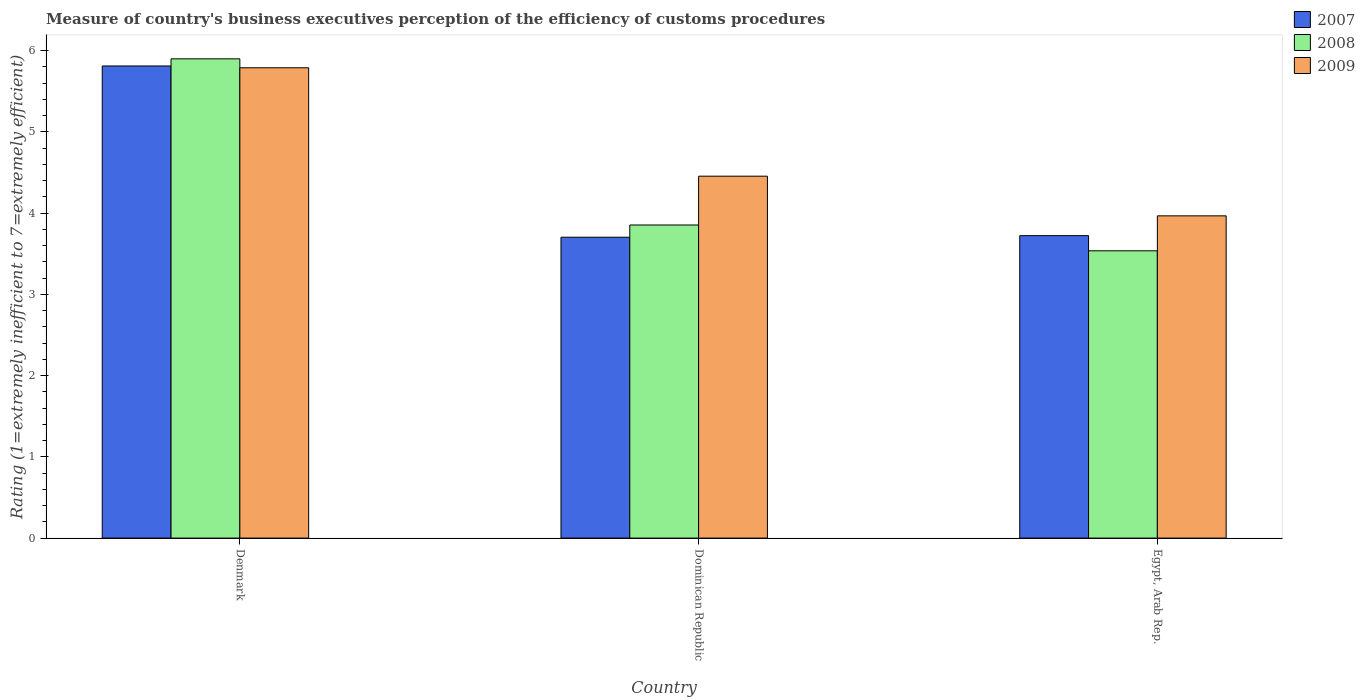How many groups of bars are there?
Give a very brief answer. 3. Are the number of bars per tick equal to the number of legend labels?
Ensure brevity in your answer.  Yes. What is the label of the 3rd group of bars from the left?
Your answer should be compact. Egypt, Arab Rep. What is the rating of the efficiency of customs procedure in 2009 in Denmark?
Offer a very short reply. 5.79. Across all countries, what is the maximum rating of the efficiency of customs procedure in 2009?
Give a very brief answer. 5.79. Across all countries, what is the minimum rating of the efficiency of customs procedure in 2008?
Provide a succinct answer. 3.54. In which country was the rating of the efficiency of customs procedure in 2008 minimum?
Make the answer very short. Egypt, Arab Rep. What is the total rating of the efficiency of customs procedure in 2008 in the graph?
Your answer should be compact. 13.29. What is the difference between the rating of the efficiency of customs procedure in 2007 in Dominican Republic and that in Egypt, Arab Rep.?
Keep it short and to the point. -0.02. What is the difference between the rating of the efficiency of customs procedure in 2008 in Denmark and the rating of the efficiency of customs procedure in 2009 in Egypt, Arab Rep.?
Make the answer very short. 1.93. What is the average rating of the efficiency of customs procedure in 2007 per country?
Your answer should be very brief. 4.41. What is the difference between the rating of the efficiency of customs procedure of/in 2009 and rating of the efficiency of customs procedure of/in 2007 in Dominican Republic?
Your answer should be very brief. 0.75. What is the ratio of the rating of the efficiency of customs procedure in 2009 in Denmark to that in Dominican Republic?
Keep it short and to the point. 1.3. What is the difference between the highest and the second highest rating of the efficiency of customs procedure in 2008?
Provide a succinct answer. -0.32. What is the difference between the highest and the lowest rating of the efficiency of customs procedure in 2007?
Ensure brevity in your answer.  2.11. In how many countries, is the rating of the efficiency of customs procedure in 2009 greater than the average rating of the efficiency of customs procedure in 2009 taken over all countries?
Your answer should be compact. 1. Is the sum of the rating of the efficiency of customs procedure in 2008 in Dominican Republic and Egypt, Arab Rep. greater than the maximum rating of the efficiency of customs procedure in 2007 across all countries?
Offer a very short reply. Yes. What does the 2nd bar from the left in Egypt, Arab Rep. represents?
Offer a terse response. 2008. Is it the case that in every country, the sum of the rating of the efficiency of customs procedure in 2008 and rating of the efficiency of customs procedure in 2009 is greater than the rating of the efficiency of customs procedure in 2007?
Offer a very short reply. Yes. How many bars are there?
Your answer should be very brief. 9. Are the values on the major ticks of Y-axis written in scientific E-notation?
Ensure brevity in your answer.  No. Does the graph contain any zero values?
Your answer should be compact. No. Where does the legend appear in the graph?
Your answer should be very brief. Top right. How many legend labels are there?
Make the answer very short. 3. What is the title of the graph?
Keep it short and to the point. Measure of country's business executives perception of the efficiency of customs procedures. What is the label or title of the Y-axis?
Give a very brief answer. Rating (1=extremely inefficient to 7=extremely efficient). What is the Rating (1=extremely inefficient to 7=extremely efficient) of 2007 in Denmark?
Keep it short and to the point. 5.81. What is the Rating (1=extremely inefficient to 7=extremely efficient) of 2008 in Denmark?
Provide a short and direct response. 5.9. What is the Rating (1=extremely inefficient to 7=extremely efficient) in 2009 in Denmark?
Your answer should be compact. 5.79. What is the Rating (1=extremely inefficient to 7=extremely efficient) of 2007 in Dominican Republic?
Keep it short and to the point. 3.7. What is the Rating (1=extremely inefficient to 7=extremely efficient) in 2008 in Dominican Republic?
Your answer should be very brief. 3.85. What is the Rating (1=extremely inefficient to 7=extremely efficient) of 2009 in Dominican Republic?
Your response must be concise. 4.46. What is the Rating (1=extremely inefficient to 7=extremely efficient) of 2007 in Egypt, Arab Rep.?
Provide a short and direct response. 3.72. What is the Rating (1=extremely inefficient to 7=extremely efficient) of 2008 in Egypt, Arab Rep.?
Offer a terse response. 3.54. What is the Rating (1=extremely inefficient to 7=extremely efficient) in 2009 in Egypt, Arab Rep.?
Offer a very short reply. 3.97. Across all countries, what is the maximum Rating (1=extremely inefficient to 7=extremely efficient) of 2007?
Keep it short and to the point. 5.81. Across all countries, what is the maximum Rating (1=extremely inefficient to 7=extremely efficient) of 2008?
Provide a short and direct response. 5.9. Across all countries, what is the maximum Rating (1=extremely inefficient to 7=extremely efficient) in 2009?
Offer a very short reply. 5.79. Across all countries, what is the minimum Rating (1=extremely inefficient to 7=extremely efficient) in 2007?
Offer a very short reply. 3.7. Across all countries, what is the minimum Rating (1=extremely inefficient to 7=extremely efficient) of 2008?
Offer a very short reply. 3.54. Across all countries, what is the minimum Rating (1=extremely inefficient to 7=extremely efficient) in 2009?
Make the answer very short. 3.97. What is the total Rating (1=extremely inefficient to 7=extremely efficient) in 2007 in the graph?
Your answer should be very brief. 13.24. What is the total Rating (1=extremely inefficient to 7=extremely efficient) in 2008 in the graph?
Provide a succinct answer. 13.29. What is the total Rating (1=extremely inefficient to 7=extremely efficient) in 2009 in the graph?
Make the answer very short. 14.21. What is the difference between the Rating (1=extremely inefficient to 7=extremely efficient) in 2007 in Denmark and that in Dominican Republic?
Make the answer very short. 2.11. What is the difference between the Rating (1=extremely inefficient to 7=extremely efficient) in 2008 in Denmark and that in Dominican Republic?
Give a very brief answer. 2.05. What is the difference between the Rating (1=extremely inefficient to 7=extremely efficient) of 2009 in Denmark and that in Dominican Republic?
Offer a very short reply. 1.33. What is the difference between the Rating (1=extremely inefficient to 7=extremely efficient) in 2007 in Denmark and that in Egypt, Arab Rep.?
Your response must be concise. 2.09. What is the difference between the Rating (1=extremely inefficient to 7=extremely efficient) in 2008 in Denmark and that in Egypt, Arab Rep.?
Provide a succinct answer. 2.36. What is the difference between the Rating (1=extremely inefficient to 7=extremely efficient) in 2009 in Denmark and that in Egypt, Arab Rep.?
Offer a terse response. 1.82. What is the difference between the Rating (1=extremely inefficient to 7=extremely efficient) of 2007 in Dominican Republic and that in Egypt, Arab Rep.?
Offer a very short reply. -0.02. What is the difference between the Rating (1=extremely inefficient to 7=extremely efficient) of 2008 in Dominican Republic and that in Egypt, Arab Rep.?
Offer a terse response. 0.32. What is the difference between the Rating (1=extremely inefficient to 7=extremely efficient) of 2009 in Dominican Republic and that in Egypt, Arab Rep.?
Your response must be concise. 0.49. What is the difference between the Rating (1=extremely inefficient to 7=extremely efficient) in 2007 in Denmark and the Rating (1=extremely inefficient to 7=extremely efficient) in 2008 in Dominican Republic?
Make the answer very short. 1.96. What is the difference between the Rating (1=extremely inefficient to 7=extremely efficient) in 2007 in Denmark and the Rating (1=extremely inefficient to 7=extremely efficient) in 2009 in Dominican Republic?
Offer a very short reply. 1.36. What is the difference between the Rating (1=extremely inefficient to 7=extremely efficient) in 2008 in Denmark and the Rating (1=extremely inefficient to 7=extremely efficient) in 2009 in Dominican Republic?
Give a very brief answer. 1.44. What is the difference between the Rating (1=extremely inefficient to 7=extremely efficient) in 2007 in Denmark and the Rating (1=extremely inefficient to 7=extremely efficient) in 2008 in Egypt, Arab Rep.?
Offer a very short reply. 2.28. What is the difference between the Rating (1=extremely inefficient to 7=extremely efficient) of 2007 in Denmark and the Rating (1=extremely inefficient to 7=extremely efficient) of 2009 in Egypt, Arab Rep.?
Your answer should be very brief. 1.84. What is the difference between the Rating (1=extremely inefficient to 7=extremely efficient) in 2008 in Denmark and the Rating (1=extremely inefficient to 7=extremely efficient) in 2009 in Egypt, Arab Rep.?
Your response must be concise. 1.93. What is the difference between the Rating (1=extremely inefficient to 7=extremely efficient) in 2007 in Dominican Republic and the Rating (1=extremely inefficient to 7=extremely efficient) in 2008 in Egypt, Arab Rep.?
Your response must be concise. 0.17. What is the difference between the Rating (1=extremely inefficient to 7=extremely efficient) of 2007 in Dominican Republic and the Rating (1=extremely inefficient to 7=extremely efficient) of 2009 in Egypt, Arab Rep.?
Your response must be concise. -0.26. What is the difference between the Rating (1=extremely inefficient to 7=extremely efficient) of 2008 in Dominican Republic and the Rating (1=extremely inefficient to 7=extremely efficient) of 2009 in Egypt, Arab Rep.?
Your response must be concise. -0.11. What is the average Rating (1=extremely inefficient to 7=extremely efficient) of 2007 per country?
Give a very brief answer. 4.41. What is the average Rating (1=extremely inefficient to 7=extremely efficient) of 2008 per country?
Provide a short and direct response. 4.43. What is the average Rating (1=extremely inefficient to 7=extremely efficient) of 2009 per country?
Make the answer very short. 4.74. What is the difference between the Rating (1=extremely inefficient to 7=extremely efficient) in 2007 and Rating (1=extremely inefficient to 7=extremely efficient) in 2008 in Denmark?
Offer a terse response. -0.09. What is the difference between the Rating (1=extremely inefficient to 7=extremely efficient) of 2007 and Rating (1=extremely inefficient to 7=extremely efficient) of 2009 in Denmark?
Provide a succinct answer. 0.02. What is the difference between the Rating (1=extremely inefficient to 7=extremely efficient) in 2008 and Rating (1=extremely inefficient to 7=extremely efficient) in 2009 in Denmark?
Your answer should be very brief. 0.11. What is the difference between the Rating (1=extremely inefficient to 7=extremely efficient) of 2007 and Rating (1=extremely inefficient to 7=extremely efficient) of 2008 in Dominican Republic?
Provide a short and direct response. -0.15. What is the difference between the Rating (1=extremely inefficient to 7=extremely efficient) of 2007 and Rating (1=extremely inefficient to 7=extremely efficient) of 2009 in Dominican Republic?
Your answer should be compact. -0.75. What is the difference between the Rating (1=extremely inefficient to 7=extremely efficient) in 2008 and Rating (1=extremely inefficient to 7=extremely efficient) in 2009 in Dominican Republic?
Your answer should be compact. -0.6. What is the difference between the Rating (1=extremely inefficient to 7=extremely efficient) in 2007 and Rating (1=extremely inefficient to 7=extremely efficient) in 2008 in Egypt, Arab Rep.?
Your answer should be compact. 0.19. What is the difference between the Rating (1=extremely inefficient to 7=extremely efficient) of 2007 and Rating (1=extremely inefficient to 7=extremely efficient) of 2009 in Egypt, Arab Rep.?
Your answer should be very brief. -0.24. What is the difference between the Rating (1=extremely inefficient to 7=extremely efficient) of 2008 and Rating (1=extremely inefficient to 7=extremely efficient) of 2009 in Egypt, Arab Rep.?
Provide a short and direct response. -0.43. What is the ratio of the Rating (1=extremely inefficient to 7=extremely efficient) of 2007 in Denmark to that in Dominican Republic?
Make the answer very short. 1.57. What is the ratio of the Rating (1=extremely inefficient to 7=extremely efficient) in 2008 in Denmark to that in Dominican Republic?
Provide a short and direct response. 1.53. What is the ratio of the Rating (1=extremely inefficient to 7=extremely efficient) of 2009 in Denmark to that in Dominican Republic?
Your answer should be very brief. 1.3. What is the ratio of the Rating (1=extremely inefficient to 7=extremely efficient) of 2007 in Denmark to that in Egypt, Arab Rep.?
Provide a succinct answer. 1.56. What is the ratio of the Rating (1=extremely inefficient to 7=extremely efficient) in 2008 in Denmark to that in Egypt, Arab Rep.?
Provide a succinct answer. 1.67. What is the ratio of the Rating (1=extremely inefficient to 7=extremely efficient) of 2009 in Denmark to that in Egypt, Arab Rep.?
Ensure brevity in your answer.  1.46. What is the ratio of the Rating (1=extremely inefficient to 7=extremely efficient) of 2007 in Dominican Republic to that in Egypt, Arab Rep.?
Provide a short and direct response. 0.99. What is the ratio of the Rating (1=extremely inefficient to 7=extremely efficient) in 2008 in Dominican Republic to that in Egypt, Arab Rep.?
Provide a short and direct response. 1.09. What is the ratio of the Rating (1=extremely inefficient to 7=extremely efficient) in 2009 in Dominican Republic to that in Egypt, Arab Rep.?
Offer a very short reply. 1.12. What is the difference between the highest and the second highest Rating (1=extremely inefficient to 7=extremely efficient) in 2007?
Offer a terse response. 2.09. What is the difference between the highest and the second highest Rating (1=extremely inefficient to 7=extremely efficient) in 2008?
Provide a succinct answer. 2.05. What is the difference between the highest and the second highest Rating (1=extremely inefficient to 7=extremely efficient) of 2009?
Keep it short and to the point. 1.33. What is the difference between the highest and the lowest Rating (1=extremely inefficient to 7=extremely efficient) of 2007?
Give a very brief answer. 2.11. What is the difference between the highest and the lowest Rating (1=extremely inefficient to 7=extremely efficient) in 2008?
Offer a very short reply. 2.36. What is the difference between the highest and the lowest Rating (1=extremely inefficient to 7=extremely efficient) of 2009?
Give a very brief answer. 1.82. 